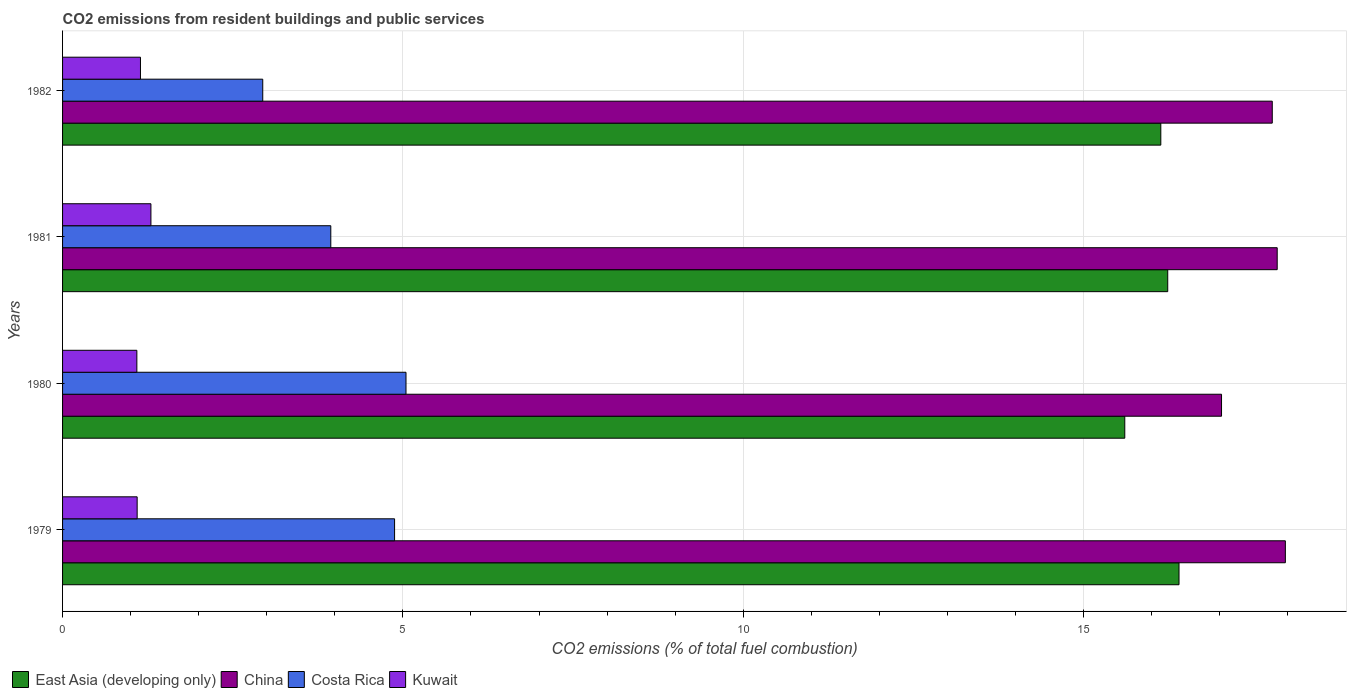How many different coloured bars are there?
Offer a very short reply. 4. How many groups of bars are there?
Your answer should be compact. 4. Are the number of bars per tick equal to the number of legend labels?
Give a very brief answer. Yes. Are the number of bars on each tick of the Y-axis equal?
Provide a succinct answer. Yes. How many bars are there on the 1st tick from the top?
Your answer should be compact. 4. What is the total CO2 emitted in East Asia (developing only) in 1981?
Your answer should be very brief. 16.24. Across all years, what is the maximum total CO2 emitted in Costa Rica?
Your answer should be very brief. 5.05. Across all years, what is the minimum total CO2 emitted in China?
Your response must be concise. 17.03. In which year was the total CO2 emitted in China maximum?
Your answer should be compact. 1979. In which year was the total CO2 emitted in East Asia (developing only) minimum?
Provide a succinct answer. 1980. What is the total total CO2 emitted in China in the graph?
Your response must be concise. 70.61. What is the difference between the total CO2 emitted in Costa Rica in 1979 and that in 1982?
Provide a succinct answer. 1.94. What is the difference between the total CO2 emitted in Costa Rica in 1979 and the total CO2 emitted in China in 1982?
Offer a very short reply. -12.89. What is the average total CO2 emitted in China per year?
Provide a succinct answer. 17.65. In the year 1980, what is the difference between the total CO2 emitted in Costa Rica and total CO2 emitted in East Asia (developing only)?
Offer a terse response. -10.56. In how many years, is the total CO2 emitted in China greater than 1 ?
Your response must be concise. 4. What is the ratio of the total CO2 emitted in East Asia (developing only) in 1979 to that in 1981?
Make the answer very short. 1.01. Is the total CO2 emitted in Costa Rica in 1979 less than that in 1980?
Provide a short and direct response. Yes. What is the difference between the highest and the second highest total CO2 emitted in Kuwait?
Provide a succinct answer. 0.15. What is the difference between the highest and the lowest total CO2 emitted in East Asia (developing only)?
Your answer should be compact. 0.8. In how many years, is the total CO2 emitted in Kuwait greater than the average total CO2 emitted in Kuwait taken over all years?
Make the answer very short. 1. What does the 2nd bar from the top in 1981 represents?
Ensure brevity in your answer.  Costa Rica. What does the 2nd bar from the bottom in 1980 represents?
Make the answer very short. China. Is it the case that in every year, the sum of the total CO2 emitted in East Asia (developing only) and total CO2 emitted in Costa Rica is greater than the total CO2 emitted in China?
Your answer should be compact. Yes. How many bars are there?
Offer a terse response. 16. Does the graph contain grids?
Keep it short and to the point. Yes. Where does the legend appear in the graph?
Offer a very short reply. Bottom left. How are the legend labels stacked?
Provide a short and direct response. Horizontal. What is the title of the graph?
Offer a terse response. CO2 emissions from resident buildings and public services. Does "High income: nonOECD" appear as one of the legend labels in the graph?
Give a very brief answer. No. What is the label or title of the X-axis?
Offer a very short reply. CO2 emissions (% of total fuel combustion). What is the CO2 emissions (% of total fuel combustion) of East Asia (developing only) in 1979?
Keep it short and to the point. 16.4. What is the CO2 emissions (% of total fuel combustion) in China in 1979?
Your response must be concise. 17.97. What is the CO2 emissions (% of total fuel combustion) in Costa Rica in 1979?
Your answer should be compact. 4.88. What is the CO2 emissions (% of total fuel combustion) of Kuwait in 1979?
Offer a terse response. 1.1. What is the CO2 emissions (% of total fuel combustion) of East Asia (developing only) in 1980?
Keep it short and to the point. 15.61. What is the CO2 emissions (% of total fuel combustion) of China in 1980?
Make the answer very short. 17.03. What is the CO2 emissions (% of total fuel combustion) in Costa Rica in 1980?
Provide a succinct answer. 5.05. What is the CO2 emissions (% of total fuel combustion) of Kuwait in 1980?
Offer a very short reply. 1.09. What is the CO2 emissions (% of total fuel combustion) of East Asia (developing only) in 1981?
Ensure brevity in your answer.  16.24. What is the CO2 emissions (% of total fuel combustion) of China in 1981?
Offer a very short reply. 17.85. What is the CO2 emissions (% of total fuel combustion) of Costa Rica in 1981?
Your answer should be very brief. 3.94. What is the CO2 emissions (% of total fuel combustion) of Kuwait in 1981?
Offer a very short reply. 1.3. What is the CO2 emissions (% of total fuel combustion) in East Asia (developing only) in 1982?
Ensure brevity in your answer.  16.14. What is the CO2 emissions (% of total fuel combustion) of China in 1982?
Ensure brevity in your answer.  17.77. What is the CO2 emissions (% of total fuel combustion) of Costa Rica in 1982?
Offer a very short reply. 2.94. What is the CO2 emissions (% of total fuel combustion) of Kuwait in 1982?
Provide a succinct answer. 1.14. Across all years, what is the maximum CO2 emissions (% of total fuel combustion) in East Asia (developing only)?
Make the answer very short. 16.4. Across all years, what is the maximum CO2 emissions (% of total fuel combustion) of China?
Make the answer very short. 17.97. Across all years, what is the maximum CO2 emissions (% of total fuel combustion) of Costa Rica?
Your answer should be very brief. 5.05. Across all years, what is the maximum CO2 emissions (% of total fuel combustion) in Kuwait?
Your answer should be very brief. 1.3. Across all years, what is the minimum CO2 emissions (% of total fuel combustion) in East Asia (developing only)?
Provide a short and direct response. 15.61. Across all years, what is the minimum CO2 emissions (% of total fuel combustion) in China?
Offer a terse response. 17.03. Across all years, what is the minimum CO2 emissions (% of total fuel combustion) of Costa Rica?
Keep it short and to the point. 2.94. Across all years, what is the minimum CO2 emissions (% of total fuel combustion) of Kuwait?
Make the answer very short. 1.09. What is the total CO2 emissions (% of total fuel combustion) of East Asia (developing only) in the graph?
Provide a succinct answer. 64.38. What is the total CO2 emissions (% of total fuel combustion) in China in the graph?
Make the answer very short. 70.61. What is the total CO2 emissions (% of total fuel combustion) of Costa Rica in the graph?
Your answer should be compact. 16.81. What is the total CO2 emissions (% of total fuel combustion) of Kuwait in the graph?
Offer a very short reply. 4.63. What is the difference between the CO2 emissions (% of total fuel combustion) of East Asia (developing only) in 1979 and that in 1980?
Make the answer very short. 0.8. What is the difference between the CO2 emissions (% of total fuel combustion) of China in 1979 and that in 1980?
Make the answer very short. 0.94. What is the difference between the CO2 emissions (% of total fuel combustion) of Costa Rica in 1979 and that in 1980?
Offer a terse response. -0.17. What is the difference between the CO2 emissions (% of total fuel combustion) in Kuwait in 1979 and that in 1980?
Your response must be concise. 0. What is the difference between the CO2 emissions (% of total fuel combustion) of East Asia (developing only) in 1979 and that in 1981?
Your response must be concise. 0.17. What is the difference between the CO2 emissions (% of total fuel combustion) of China in 1979 and that in 1981?
Provide a succinct answer. 0.12. What is the difference between the CO2 emissions (% of total fuel combustion) in Costa Rica in 1979 and that in 1981?
Offer a very short reply. 0.94. What is the difference between the CO2 emissions (% of total fuel combustion) of Kuwait in 1979 and that in 1981?
Keep it short and to the point. -0.2. What is the difference between the CO2 emissions (% of total fuel combustion) of East Asia (developing only) in 1979 and that in 1982?
Your answer should be compact. 0.27. What is the difference between the CO2 emissions (% of total fuel combustion) of China in 1979 and that in 1982?
Your answer should be compact. 0.19. What is the difference between the CO2 emissions (% of total fuel combustion) in Costa Rica in 1979 and that in 1982?
Your answer should be very brief. 1.94. What is the difference between the CO2 emissions (% of total fuel combustion) in Kuwait in 1979 and that in 1982?
Give a very brief answer. -0.05. What is the difference between the CO2 emissions (% of total fuel combustion) of East Asia (developing only) in 1980 and that in 1981?
Your answer should be compact. -0.63. What is the difference between the CO2 emissions (% of total fuel combustion) in China in 1980 and that in 1981?
Give a very brief answer. -0.82. What is the difference between the CO2 emissions (% of total fuel combustion) in Costa Rica in 1980 and that in 1981?
Your response must be concise. 1.1. What is the difference between the CO2 emissions (% of total fuel combustion) of Kuwait in 1980 and that in 1981?
Keep it short and to the point. -0.21. What is the difference between the CO2 emissions (% of total fuel combustion) of East Asia (developing only) in 1980 and that in 1982?
Make the answer very short. -0.53. What is the difference between the CO2 emissions (% of total fuel combustion) of China in 1980 and that in 1982?
Offer a terse response. -0.75. What is the difference between the CO2 emissions (% of total fuel combustion) of Costa Rica in 1980 and that in 1982?
Provide a succinct answer. 2.1. What is the difference between the CO2 emissions (% of total fuel combustion) in Kuwait in 1980 and that in 1982?
Offer a very short reply. -0.05. What is the difference between the CO2 emissions (% of total fuel combustion) in East Asia (developing only) in 1981 and that in 1982?
Offer a very short reply. 0.1. What is the difference between the CO2 emissions (% of total fuel combustion) of China in 1981 and that in 1982?
Your answer should be very brief. 0.07. What is the difference between the CO2 emissions (% of total fuel combustion) of Kuwait in 1981 and that in 1982?
Make the answer very short. 0.15. What is the difference between the CO2 emissions (% of total fuel combustion) in East Asia (developing only) in 1979 and the CO2 emissions (% of total fuel combustion) in China in 1980?
Provide a short and direct response. -0.62. What is the difference between the CO2 emissions (% of total fuel combustion) of East Asia (developing only) in 1979 and the CO2 emissions (% of total fuel combustion) of Costa Rica in 1980?
Give a very brief answer. 11.36. What is the difference between the CO2 emissions (% of total fuel combustion) in East Asia (developing only) in 1979 and the CO2 emissions (% of total fuel combustion) in Kuwait in 1980?
Your answer should be very brief. 15.31. What is the difference between the CO2 emissions (% of total fuel combustion) in China in 1979 and the CO2 emissions (% of total fuel combustion) in Costa Rica in 1980?
Give a very brief answer. 12.92. What is the difference between the CO2 emissions (% of total fuel combustion) of China in 1979 and the CO2 emissions (% of total fuel combustion) of Kuwait in 1980?
Your answer should be very brief. 16.87. What is the difference between the CO2 emissions (% of total fuel combustion) of Costa Rica in 1979 and the CO2 emissions (% of total fuel combustion) of Kuwait in 1980?
Ensure brevity in your answer.  3.79. What is the difference between the CO2 emissions (% of total fuel combustion) in East Asia (developing only) in 1979 and the CO2 emissions (% of total fuel combustion) in China in 1981?
Provide a succinct answer. -1.44. What is the difference between the CO2 emissions (% of total fuel combustion) of East Asia (developing only) in 1979 and the CO2 emissions (% of total fuel combustion) of Costa Rica in 1981?
Make the answer very short. 12.46. What is the difference between the CO2 emissions (% of total fuel combustion) in East Asia (developing only) in 1979 and the CO2 emissions (% of total fuel combustion) in Kuwait in 1981?
Your answer should be very brief. 15.1. What is the difference between the CO2 emissions (% of total fuel combustion) of China in 1979 and the CO2 emissions (% of total fuel combustion) of Costa Rica in 1981?
Ensure brevity in your answer.  14.02. What is the difference between the CO2 emissions (% of total fuel combustion) of China in 1979 and the CO2 emissions (% of total fuel combustion) of Kuwait in 1981?
Your answer should be compact. 16.67. What is the difference between the CO2 emissions (% of total fuel combustion) in Costa Rica in 1979 and the CO2 emissions (% of total fuel combustion) in Kuwait in 1981?
Offer a terse response. 3.58. What is the difference between the CO2 emissions (% of total fuel combustion) of East Asia (developing only) in 1979 and the CO2 emissions (% of total fuel combustion) of China in 1982?
Offer a terse response. -1.37. What is the difference between the CO2 emissions (% of total fuel combustion) in East Asia (developing only) in 1979 and the CO2 emissions (% of total fuel combustion) in Costa Rica in 1982?
Give a very brief answer. 13.46. What is the difference between the CO2 emissions (% of total fuel combustion) of East Asia (developing only) in 1979 and the CO2 emissions (% of total fuel combustion) of Kuwait in 1982?
Provide a short and direct response. 15.26. What is the difference between the CO2 emissions (% of total fuel combustion) in China in 1979 and the CO2 emissions (% of total fuel combustion) in Costa Rica in 1982?
Provide a short and direct response. 15.02. What is the difference between the CO2 emissions (% of total fuel combustion) of China in 1979 and the CO2 emissions (% of total fuel combustion) of Kuwait in 1982?
Your answer should be very brief. 16.82. What is the difference between the CO2 emissions (% of total fuel combustion) in Costa Rica in 1979 and the CO2 emissions (% of total fuel combustion) in Kuwait in 1982?
Provide a short and direct response. 3.73. What is the difference between the CO2 emissions (% of total fuel combustion) of East Asia (developing only) in 1980 and the CO2 emissions (% of total fuel combustion) of China in 1981?
Make the answer very short. -2.24. What is the difference between the CO2 emissions (% of total fuel combustion) of East Asia (developing only) in 1980 and the CO2 emissions (% of total fuel combustion) of Costa Rica in 1981?
Provide a short and direct response. 11.67. What is the difference between the CO2 emissions (% of total fuel combustion) of East Asia (developing only) in 1980 and the CO2 emissions (% of total fuel combustion) of Kuwait in 1981?
Your answer should be compact. 14.31. What is the difference between the CO2 emissions (% of total fuel combustion) in China in 1980 and the CO2 emissions (% of total fuel combustion) in Costa Rica in 1981?
Provide a short and direct response. 13.09. What is the difference between the CO2 emissions (% of total fuel combustion) in China in 1980 and the CO2 emissions (% of total fuel combustion) in Kuwait in 1981?
Ensure brevity in your answer.  15.73. What is the difference between the CO2 emissions (% of total fuel combustion) of Costa Rica in 1980 and the CO2 emissions (% of total fuel combustion) of Kuwait in 1981?
Ensure brevity in your answer.  3.75. What is the difference between the CO2 emissions (% of total fuel combustion) of East Asia (developing only) in 1980 and the CO2 emissions (% of total fuel combustion) of China in 1982?
Offer a terse response. -2.17. What is the difference between the CO2 emissions (% of total fuel combustion) of East Asia (developing only) in 1980 and the CO2 emissions (% of total fuel combustion) of Costa Rica in 1982?
Your answer should be compact. 12.66. What is the difference between the CO2 emissions (% of total fuel combustion) of East Asia (developing only) in 1980 and the CO2 emissions (% of total fuel combustion) of Kuwait in 1982?
Provide a short and direct response. 14.46. What is the difference between the CO2 emissions (% of total fuel combustion) in China in 1980 and the CO2 emissions (% of total fuel combustion) in Costa Rica in 1982?
Keep it short and to the point. 14.09. What is the difference between the CO2 emissions (% of total fuel combustion) in China in 1980 and the CO2 emissions (% of total fuel combustion) in Kuwait in 1982?
Your answer should be very brief. 15.88. What is the difference between the CO2 emissions (% of total fuel combustion) of Costa Rica in 1980 and the CO2 emissions (% of total fuel combustion) of Kuwait in 1982?
Provide a short and direct response. 3.9. What is the difference between the CO2 emissions (% of total fuel combustion) in East Asia (developing only) in 1981 and the CO2 emissions (% of total fuel combustion) in China in 1982?
Your answer should be very brief. -1.54. What is the difference between the CO2 emissions (% of total fuel combustion) in East Asia (developing only) in 1981 and the CO2 emissions (% of total fuel combustion) in Costa Rica in 1982?
Your answer should be compact. 13.3. What is the difference between the CO2 emissions (% of total fuel combustion) of East Asia (developing only) in 1981 and the CO2 emissions (% of total fuel combustion) of Kuwait in 1982?
Provide a short and direct response. 15.09. What is the difference between the CO2 emissions (% of total fuel combustion) of China in 1981 and the CO2 emissions (% of total fuel combustion) of Costa Rica in 1982?
Your answer should be compact. 14.9. What is the difference between the CO2 emissions (% of total fuel combustion) of China in 1981 and the CO2 emissions (% of total fuel combustion) of Kuwait in 1982?
Keep it short and to the point. 16.7. What is the difference between the CO2 emissions (% of total fuel combustion) of Costa Rica in 1981 and the CO2 emissions (% of total fuel combustion) of Kuwait in 1982?
Offer a terse response. 2.8. What is the average CO2 emissions (% of total fuel combustion) in East Asia (developing only) per year?
Offer a very short reply. 16.1. What is the average CO2 emissions (% of total fuel combustion) in China per year?
Your response must be concise. 17.65. What is the average CO2 emissions (% of total fuel combustion) in Costa Rica per year?
Provide a succinct answer. 4.2. What is the average CO2 emissions (% of total fuel combustion) of Kuwait per year?
Your answer should be very brief. 1.16. In the year 1979, what is the difference between the CO2 emissions (% of total fuel combustion) in East Asia (developing only) and CO2 emissions (% of total fuel combustion) in China?
Your response must be concise. -1.56. In the year 1979, what is the difference between the CO2 emissions (% of total fuel combustion) in East Asia (developing only) and CO2 emissions (% of total fuel combustion) in Costa Rica?
Ensure brevity in your answer.  11.52. In the year 1979, what is the difference between the CO2 emissions (% of total fuel combustion) in East Asia (developing only) and CO2 emissions (% of total fuel combustion) in Kuwait?
Make the answer very short. 15.31. In the year 1979, what is the difference between the CO2 emissions (% of total fuel combustion) in China and CO2 emissions (% of total fuel combustion) in Costa Rica?
Give a very brief answer. 13.09. In the year 1979, what is the difference between the CO2 emissions (% of total fuel combustion) of China and CO2 emissions (% of total fuel combustion) of Kuwait?
Offer a very short reply. 16.87. In the year 1979, what is the difference between the CO2 emissions (% of total fuel combustion) in Costa Rica and CO2 emissions (% of total fuel combustion) in Kuwait?
Your response must be concise. 3.78. In the year 1980, what is the difference between the CO2 emissions (% of total fuel combustion) of East Asia (developing only) and CO2 emissions (% of total fuel combustion) of China?
Keep it short and to the point. -1.42. In the year 1980, what is the difference between the CO2 emissions (% of total fuel combustion) of East Asia (developing only) and CO2 emissions (% of total fuel combustion) of Costa Rica?
Your response must be concise. 10.56. In the year 1980, what is the difference between the CO2 emissions (% of total fuel combustion) of East Asia (developing only) and CO2 emissions (% of total fuel combustion) of Kuwait?
Your response must be concise. 14.51. In the year 1980, what is the difference between the CO2 emissions (% of total fuel combustion) of China and CO2 emissions (% of total fuel combustion) of Costa Rica?
Offer a terse response. 11.98. In the year 1980, what is the difference between the CO2 emissions (% of total fuel combustion) of China and CO2 emissions (% of total fuel combustion) of Kuwait?
Provide a short and direct response. 15.94. In the year 1980, what is the difference between the CO2 emissions (% of total fuel combustion) in Costa Rica and CO2 emissions (% of total fuel combustion) in Kuwait?
Keep it short and to the point. 3.95. In the year 1981, what is the difference between the CO2 emissions (% of total fuel combustion) of East Asia (developing only) and CO2 emissions (% of total fuel combustion) of China?
Make the answer very short. -1.61. In the year 1981, what is the difference between the CO2 emissions (% of total fuel combustion) in East Asia (developing only) and CO2 emissions (% of total fuel combustion) in Costa Rica?
Offer a terse response. 12.3. In the year 1981, what is the difference between the CO2 emissions (% of total fuel combustion) of East Asia (developing only) and CO2 emissions (% of total fuel combustion) of Kuwait?
Your response must be concise. 14.94. In the year 1981, what is the difference between the CO2 emissions (% of total fuel combustion) in China and CO2 emissions (% of total fuel combustion) in Costa Rica?
Give a very brief answer. 13.9. In the year 1981, what is the difference between the CO2 emissions (% of total fuel combustion) of China and CO2 emissions (% of total fuel combustion) of Kuwait?
Offer a very short reply. 16.55. In the year 1981, what is the difference between the CO2 emissions (% of total fuel combustion) of Costa Rica and CO2 emissions (% of total fuel combustion) of Kuwait?
Your response must be concise. 2.64. In the year 1982, what is the difference between the CO2 emissions (% of total fuel combustion) in East Asia (developing only) and CO2 emissions (% of total fuel combustion) in China?
Provide a succinct answer. -1.64. In the year 1982, what is the difference between the CO2 emissions (% of total fuel combustion) in East Asia (developing only) and CO2 emissions (% of total fuel combustion) in Costa Rica?
Your answer should be compact. 13.19. In the year 1982, what is the difference between the CO2 emissions (% of total fuel combustion) of East Asia (developing only) and CO2 emissions (% of total fuel combustion) of Kuwait?
Your answer should be very brief. 14.99. In the year 1982, what is the difference between the CO2 emissions (% of total fuel combustion) in China and CO2 emissions (% of total fuel combustion) in Costa Rica?
Keep it short and to the point. 14.83. In the year 1982, what is the difference between the CO2 emissions (% of total fuel combustion) of China and CO2 emissions (% of total fuel combustion) of Kuwait?
Ensure brevity in your answer.  16.63. In the year 1982, what is the difference between the CO2 emissions (% of total fuel combustion) in Costa Rica and CO2 emissions (% of total fuel combustion) in Kuwait?
Your answer should be compact. 1.8. What is the ratio of the CO2 emissions (% of total fuel combustion) of East Asia (developing only) in 1979 to that in 1980?
Keep it short and to the point. 1.05. What is the ratio of the CO2 emissions (% of total fuel combustion) in China in 1979 to that in 1980?
Provide a succinct answer. 1.06. What is the ratio of the CO2 emissions (% of total fuel combustion) of Costa Rica in 1979 to that in 1980?
Offer a very short reply. 0.97. What is the ratio of the CO2 emissions (% of total fuel combustion) in East Asia (developing only) in 1979 to that in 1981?
Keep it short and to the point. 1.01. What is the ratio of the CO2 emissions (% of total fuel combustion) in Costa Rica in 1979 to that in 1981?
Your response must be concise. 1.24. What is the ratio of the CO2 emissions (% of total fuel combustion) in Kuwait in 1979 to that in 1981?
Your answer should be compact. 0.84. What is the ratio of the CO2 emissions (% of total fuel combustion) of East Asia (developing only) in 1979 to that in 1982?
Give a very brief answer. 1.02. What is the ratio of the CO2 emissions (% of total fuel combustion) of China in 1979 to that in 1982?
Keep it short and to the point. 1.01. What is the ratio of the CO2 emissions (% of total fuel combustion) of Costa Rica in 1979 to that in 1982?
Your response must be concise. 1.66. What is the ratio of the CO2 emissions (% of total fuel combustion) of Kuwait in 1979 to that in 1982?
Give a very brief answer. 0.96. What is the ratio of the CO2 emissions (% of total fuel combustion) in East Asia (developing only) in 1980 to that in 1981?
Provide a succinct answer. 0.96. What is the ratio of the CO2 emissions (% of total fuel combustion) in China in 1980 to that in 1981?
Provide a short and direct response. 0.95. What is the ratio of the CO2 emissions (% of total fuel combustion) in Costa Rica in 1980 to that in 1981?
Your answer should be very brief. 1.28. What is the ratio of the CO2 emissions (% of total fuel combustion) of Kuwait in 1980 to that in 1981?
Provide a succinct answer. 0.84. What is the ratio of the CO2 emissions (% of total fuel combustion) of East Asia (developing only) in 1980 to that in 1982?
Your answer should be compact. 0.97. What is the ratio of the CO2 emissions (% of total fuel combustion) in China in 1980 to that in 1982?
Offer a very short reply. 0.96. What is the ratio of the CO2 emissions (% of total fuel combustion) in Costa Rica in 1980 to that in 1982?
Offer a terse response. 1.72. What is the ratio of the CO2 emissions (% of total fuel combustion) in Kuwait in 1980 to that in 1982?
Ensure brevity in your answer.  0.95. What is the ratio of the CO2 emissions (% of total fuel combustion) in East Asia (developing only) in 1981 to that in 1982?
Make the answer very short. 1.01. What is the ratio of the CO2 emissions (% of total fuel combustion) in Costa Rica in 1981 to that in 1982?
Provide a short and direct response. 1.34. What is the ratio of the CO2 emissions (% of total fuel combustion) of Kuwait in 1981 to that in 1982?
Provide a short and direct response. 1.13. What is the difference between the highest and the second highest CO2 emissions (% of total fuel combustion) of East Asia (developing only)?
Keep it short and to the point. 0.17. What is the difference between the highest and the second highest CO2 emissions (% of total fuel combustion) of China?
Provide a short and direct response. 0.12. What is the difference between the highest and the second highest CO2 emissions (% of total fuel combustion) in Costa Rica?
Provide a short and direct response. 0.17. What is the difference between the highest and the second highest CO2 emissions (% of total fuel combustion) in Kuwait?
Keep it short and to the point. 0.15. What is the difference between the highest and the lowest CO2 emissions (% of total fuel combustion) in East Asia (developing only)?
Your response must be concise. 0.8. What is the difference between the highest and the lowest CO2 emissions (% of total fuel combustion) of China?
Your answer should be compact. 0.94. What is the difference between the highest and the lowest CO2 emissions (% of total fuel combustion) in Costa Rica?
Give a very brief answer. 2.1. What is the difference between the highest and the lowest CO2 emissions (% of total fuel combustion) in Kuwait?
Offer a very short reply. 0.21. 